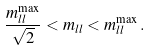<formula> <loc_0><loc_0><loc_500><loc_500>\frac { m _ { l l } ^ { \max } } { \sqrt { 2 } } < m _ { l l } < m _ { l l } ^ { \max } \, .</formula> 